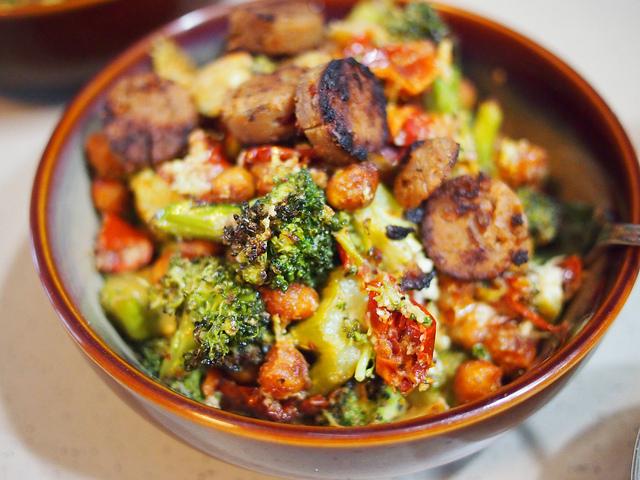Is this soup?
Be succinct. No. What vegetables are in this food?
Give a very brief answer. Broccoli. Is this food tasty?
Give a very brief answer. Yes. 